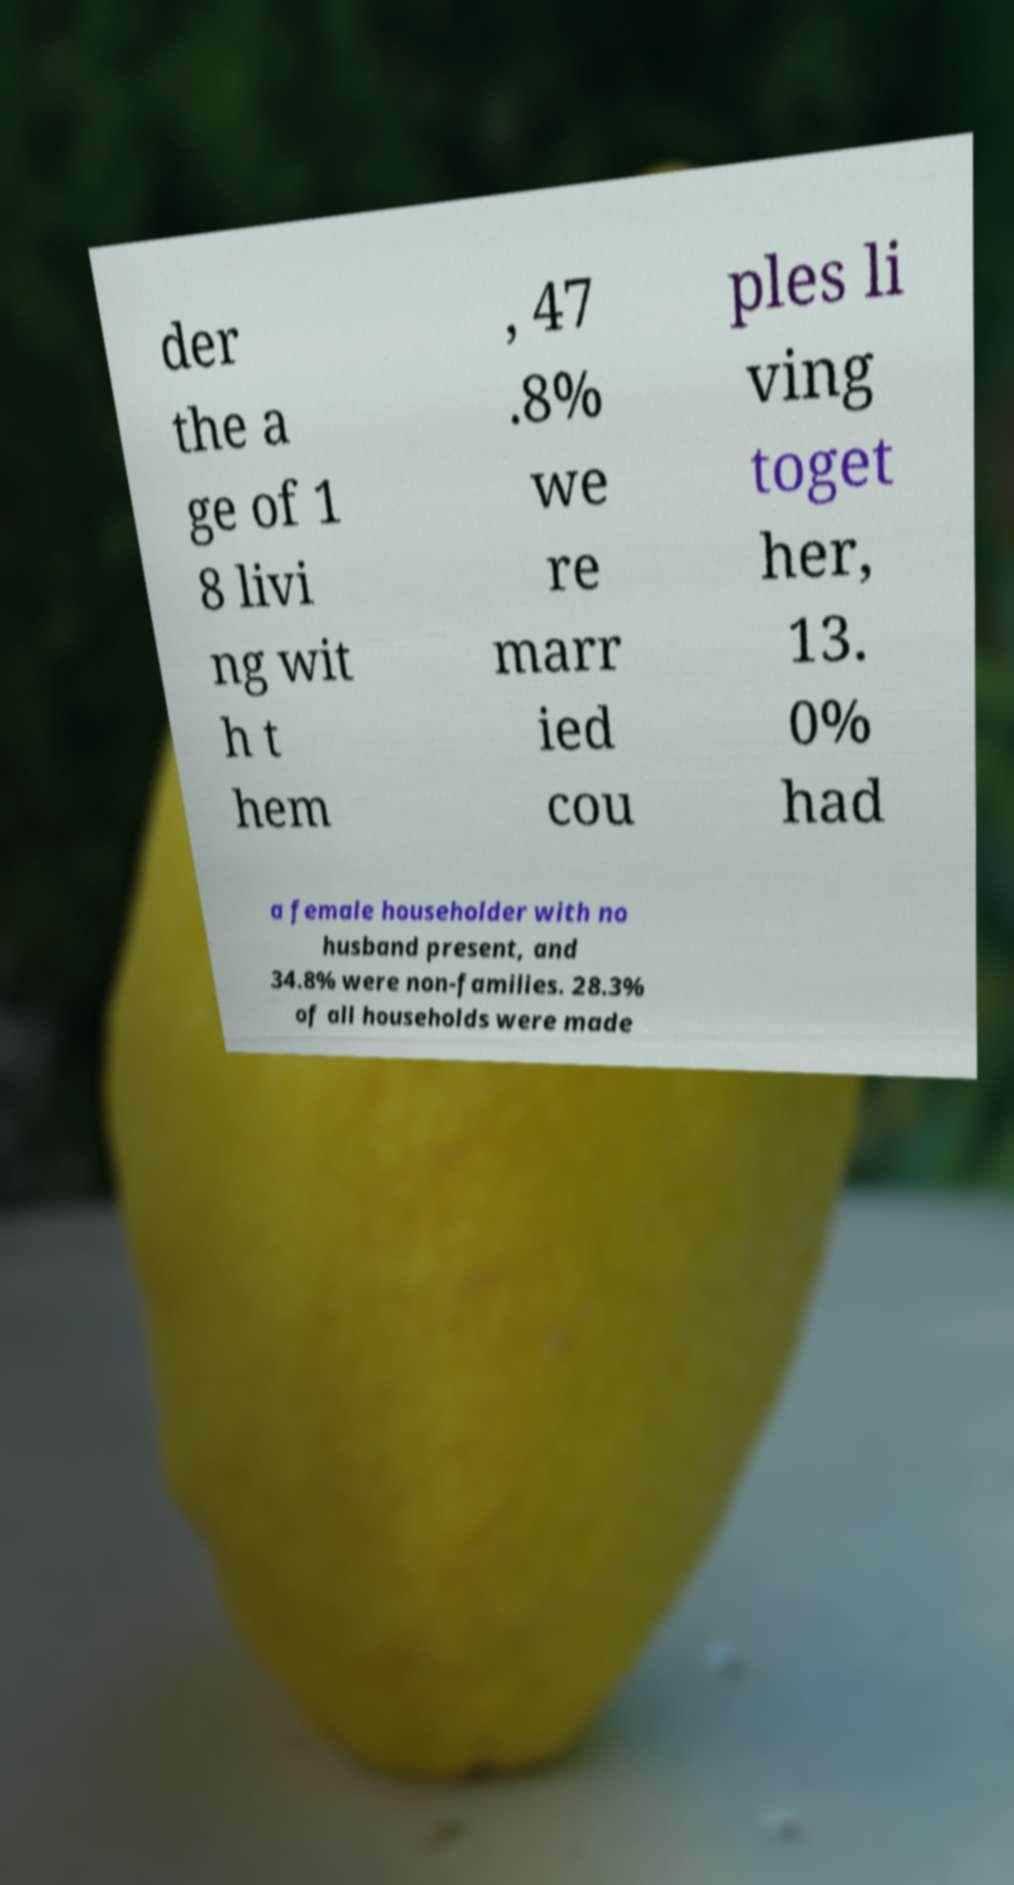There's text embedded in this image that I need extracted. Can you transcribe it verbatim? der the a ge of 1 8 livi ng wit h t hem , 47 .8% we re marr ied cou ples li ving toget her, 13. 0% had a female householder with no husband present, and 34.8% were non-families. 28.3% of all households were made 